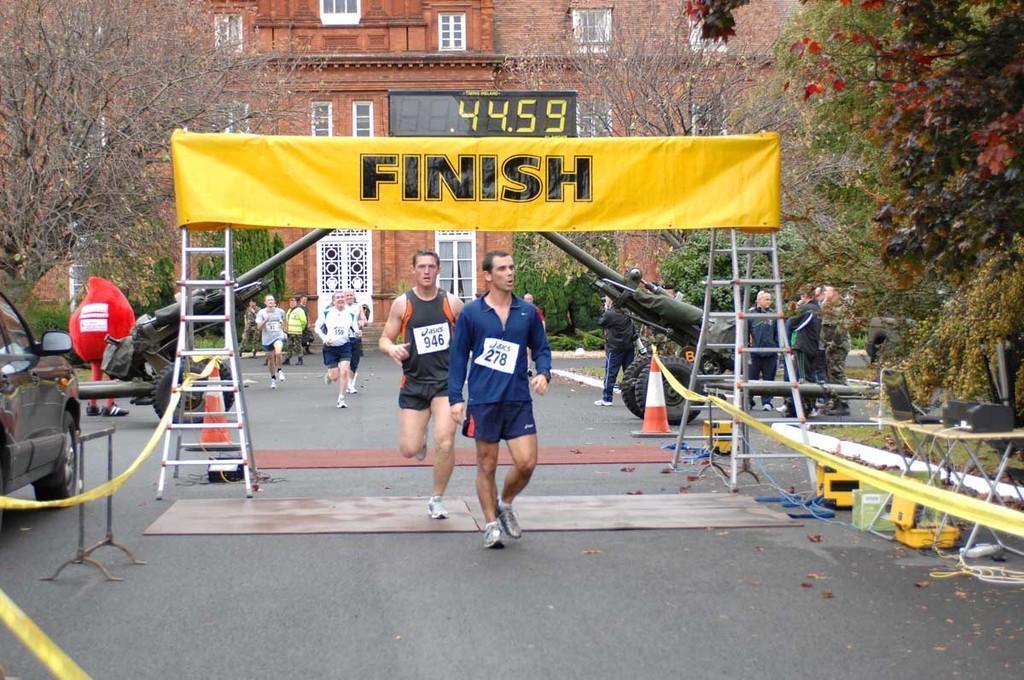Describe this image in one or two sentences. In this image, we can see people running and some are standing. In the background, there are buildings, trees and we can see a timer, a clown, some vehicles, traffic cones, ribbons, ladders and there is a banner and some windows and some stands. At the bottom, there are mars and we can see some other objects on the road. 